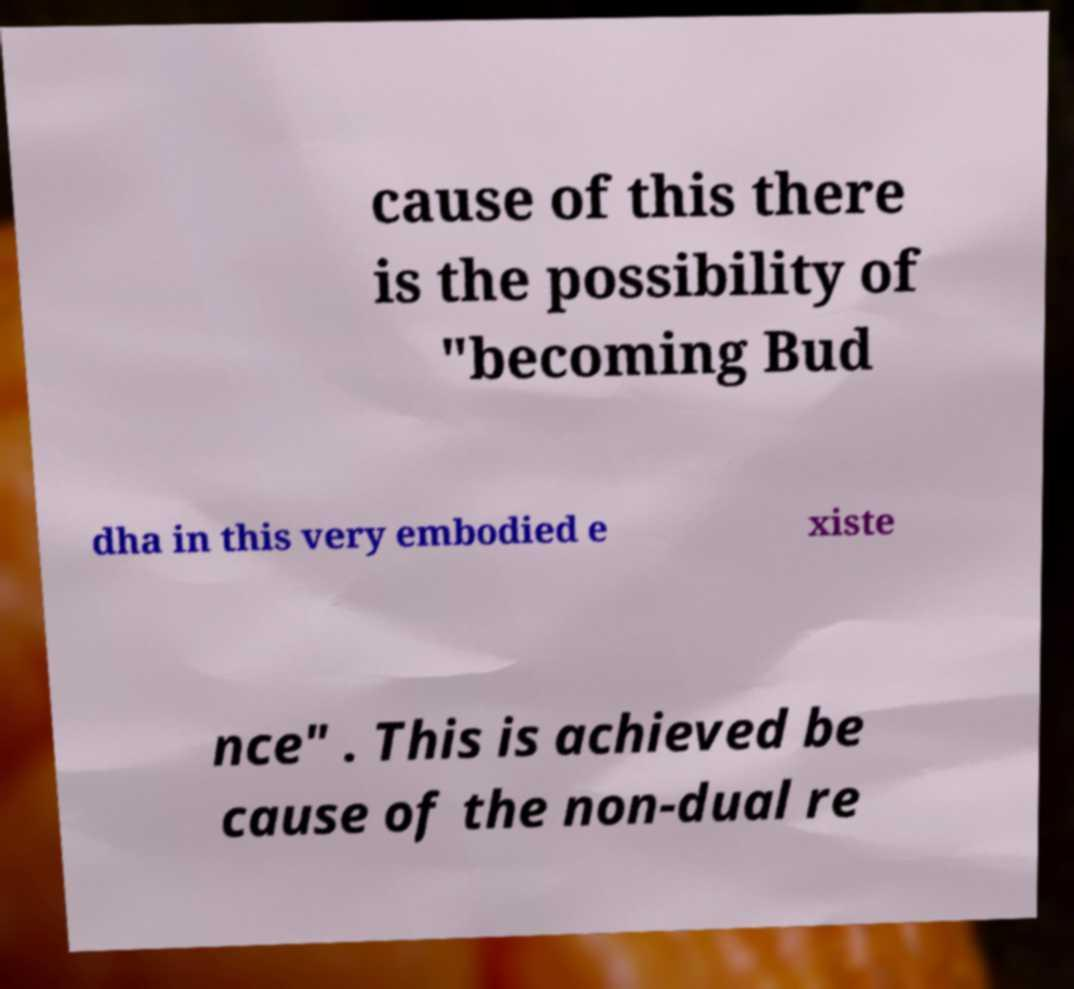Could you extract and type out the text from this image? cause of this there is the possibility of "becoming Bud dha in this very embodied e xiste nce" . This is achieved be cause of the non-dual re 